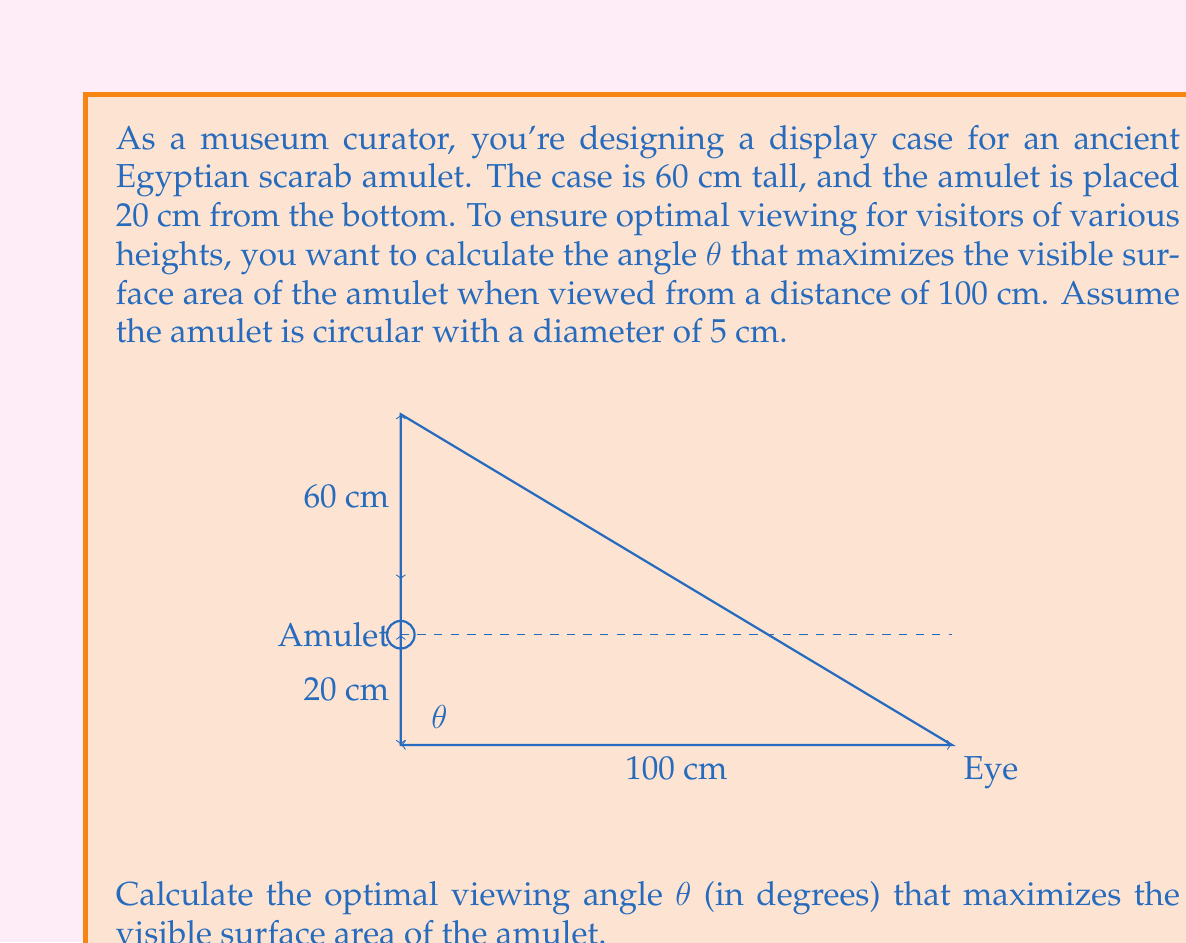Show me your answer to this math problem. To solve this problem, we'll follow these steps:

1) The visible surface area of a circular object is proportional to the sine of the viewing angle. Therefore, we need to maximize sin(θ).

2) We can express sin(θ) in terms of the triangle formed by the viewer's eye, the amulet, and the base of the display case:

   $$\sin(\theta) = \frac{\text{opposite}}{\text{hypotenuse}} = \frac{h}{d}$$

   where h is the height of the amulet above the viewer's eye level, and d is the distance from the viewer to the display case.

3) The height h depends on the viewing angle θ:

   $$h = 20 - y = 20 - (60 - 20)\tan(\theta)$$

   where y is the height difference between the viewer's eye and the top of the case.

4) Substituting this into our sin(θ) equation:

   $$\sin(\theta) = \frac{20 - 40\tan(\theta)}{100}$$

5) To find the maximum, we differentiate with respect to θ and set it to zero:

   $$\frac{d}{d\theta}(\sin(\theta)) = \frac{1}{100}(20\sec^2(\theta) - 40\sec^2(\theta)\tan(\theta)) = 0$$

6) Simplifying:

   $$20 - 40\tan(\theta) = 0$$
   $$\tan(\theta) = \frac{1}{2}$$

7) Taking the inverse tangent:

   $$\theta = \arctan(\frac{1}{2}) \approx 26.57°$$

This angle maximizes the visible surface area of the amulet for a typical viewer.
Answer: $26.57°$ 